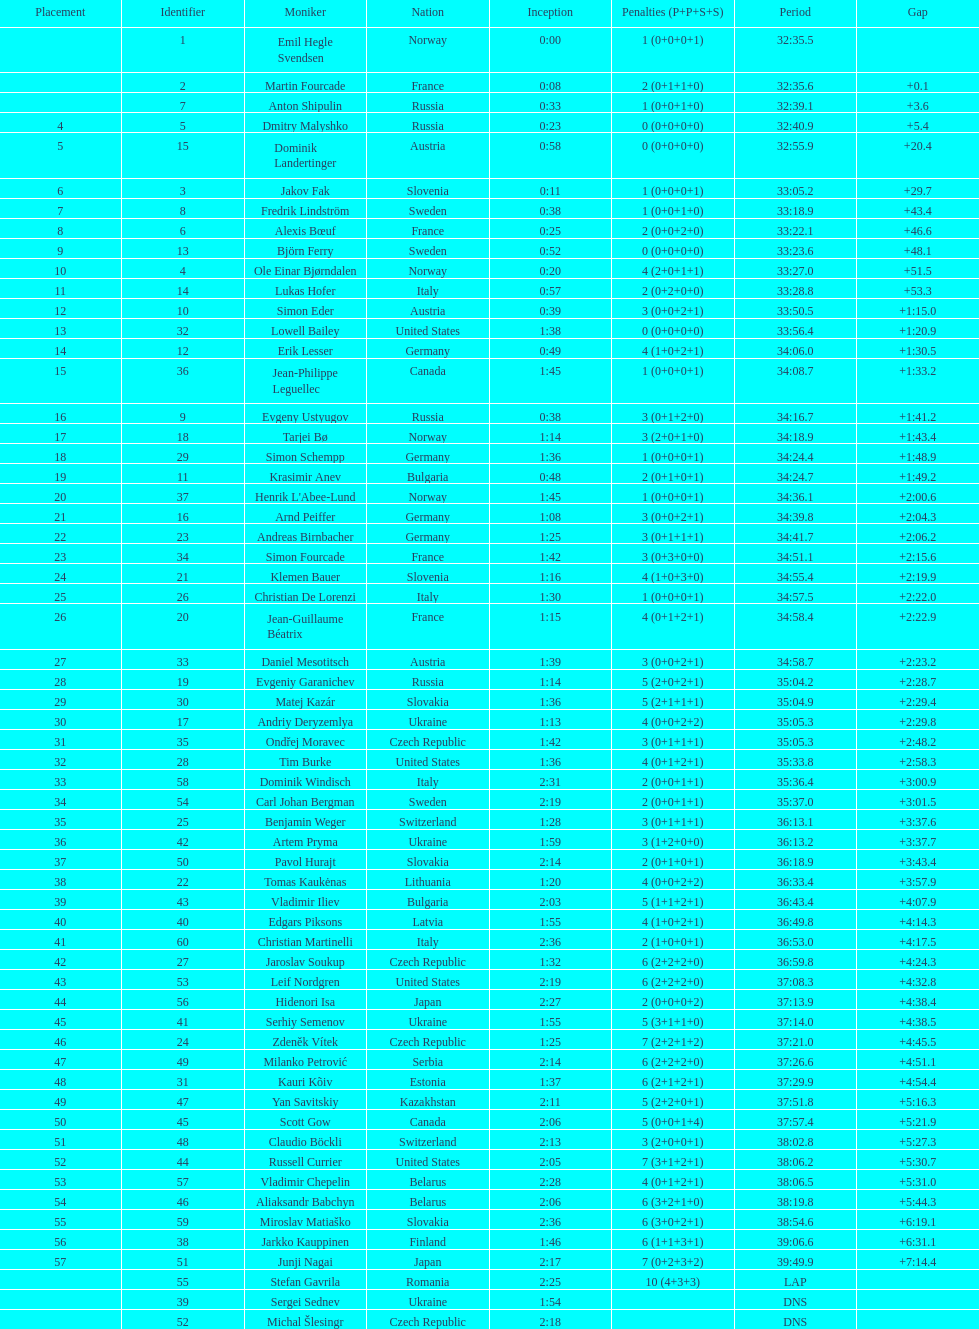How many took at least 35:00 to finish? 30. 